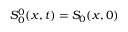<formula> <loc_0><loc_0><loc_500><loc_500>S _ { 0 } ^ { 0 } ( x , t ) = S _ { 0 } ( x , 0 )</formula> 